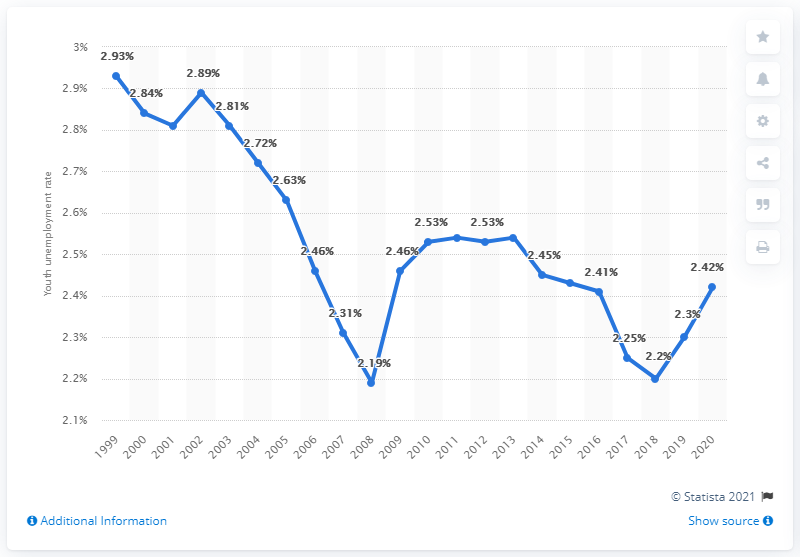Indicate a few pertinent items in this graphic. The youth unemployment rate in Nepal was 2.42% in 2020. 